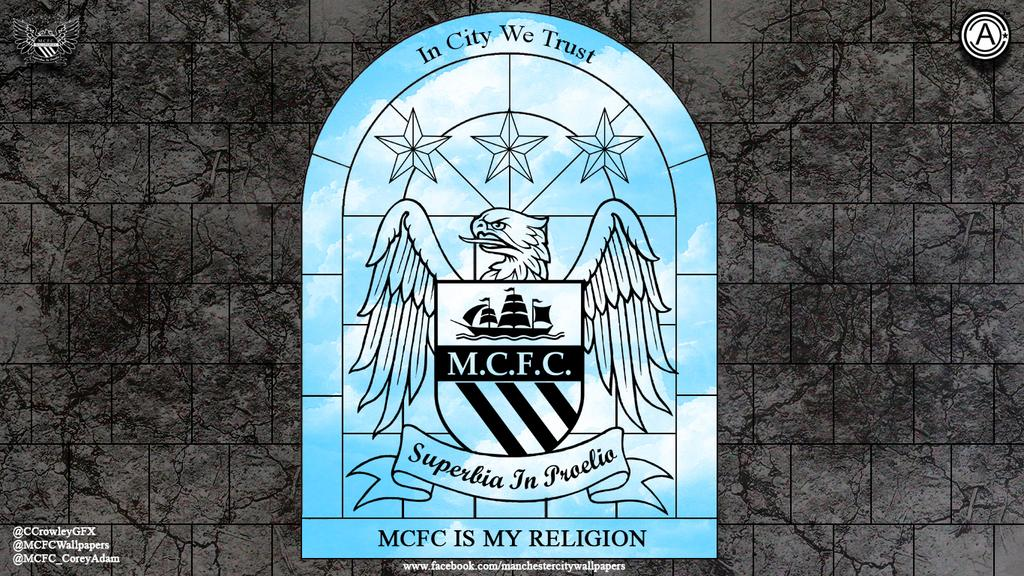<image>
Render a clear and concise summary of the photo. A picture of an eagle has the phrase MCFC is my religion on the bottom. 